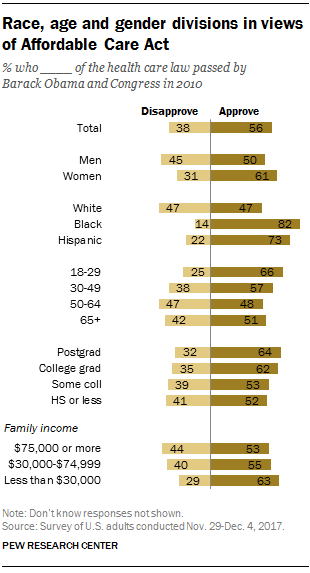Highlight a few significant elements in this photo. The value of the first longest bar in the graph is 82. What is the difference between the highest and lowest yellow bar? 35..." is a question asking for an explanation or comparison between two things. 